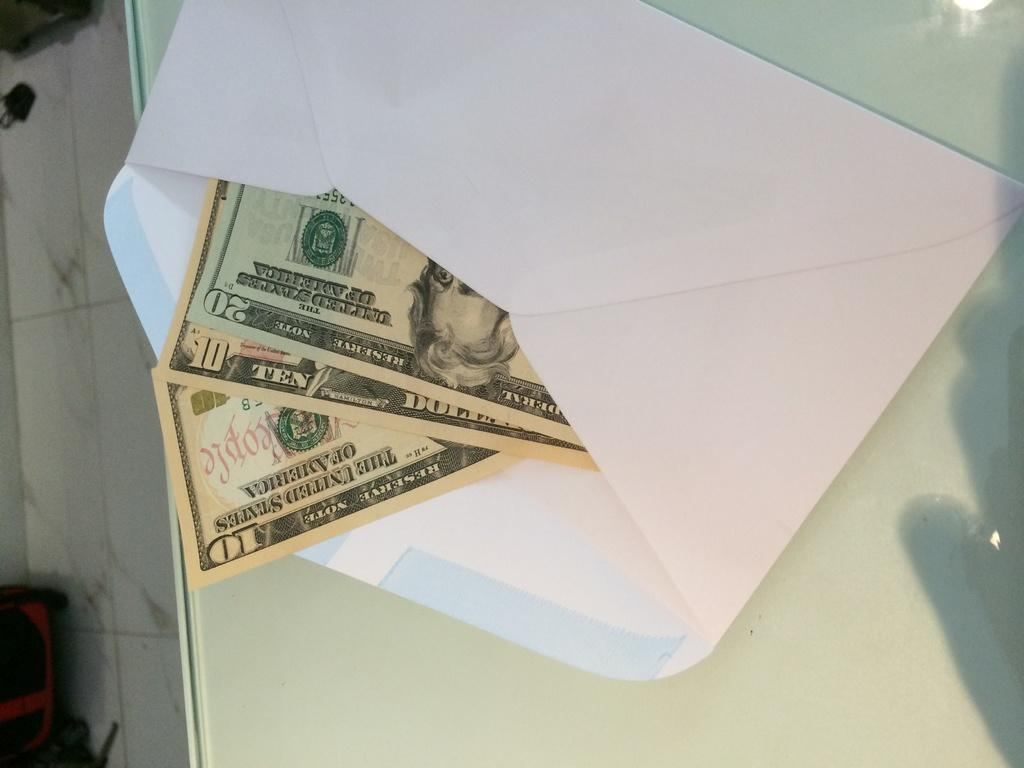<image>
Give a short and clear explanation of the subsequent image. Bills for 10 and 20 Reserve Notes in an envelope on a table 